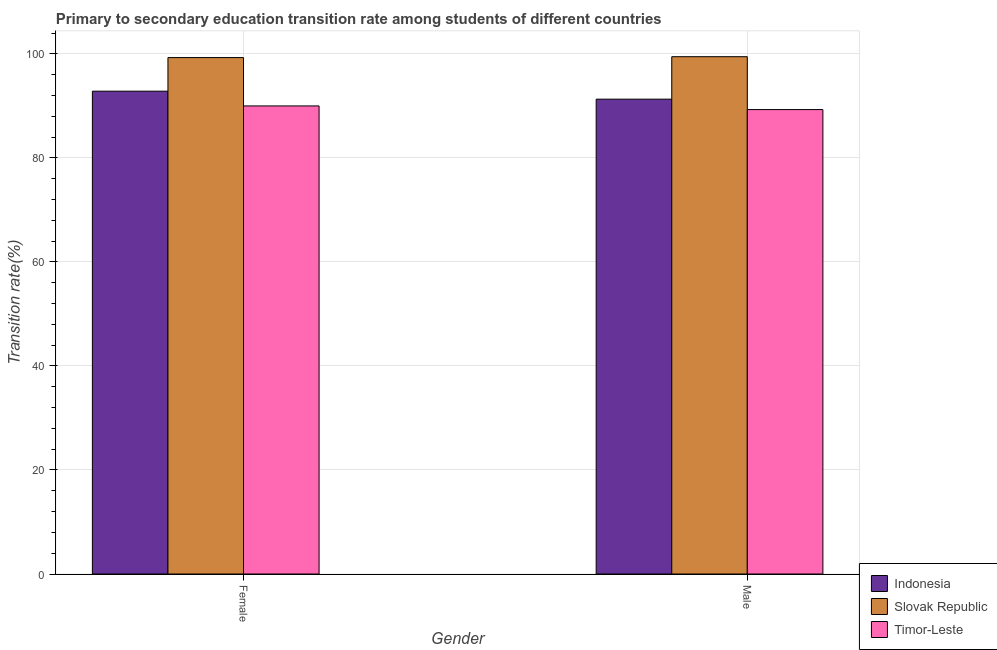How many different coloured bars are there?
Offer a very short reply. 3. Are the number of bars on each tick of the X-axis equal?
Offer a terse response. Yes. What is the transition rate among female students in Indonesia?
Give a very brief answer. 92.84. Across all countries, what is the maximum transition rate among male students?
Ensure brevity in your answer.  99.47. Across all countries, what is the minimum transition rate among male students?
Keep it short and to the point. 89.3. In which country was the transition rate among female students maximum?
Your answer should be compact. Slovak Republic. In which country was the transition rate among male students minimum?
Keep it short and to the point. Timor-Leste. What is the total transition rate among female students in the graph?
Make the answer very short. 282.15. What is the difference between the transition rate among female students in Timor-Leste and that in Slovak Republic?
Make the answer very short. -9.29. What is the difference between the transition rate among female students in Slovak Republic and the transition rate among male students in Timor-Leste?
Keep it short and to the point. 10. What is the average transition rate among female students per country?
Make the answer very short. 94.05. What is the difference between the transition rate among female students and transition rate among male students in Indonesia?
Your response must be concise. 1.54. What is the ratio of the transition rate among male students in Slovak Republic to that in Indonesia?
Provide a succinct answer. 1.09. What does the 2nd bar from the left in Female represents?
Your answer should be compact. Slovak Republic. What does the 1st bar from the right in Male represents?
Keep it short and to the point. Timor-Leste. How many bars are there?
Keep it short and to the point. 6. Are all the bars in the graph horizontal?
Keep it short and to the point. No. What is the difference between two consecutive major ticks on the Y-axis?
Make the answer very short. 20. Are the values on the major ticks of Y-axis written in scientific E-notation?
Give a very brief answer. No. Does the graph contain any zero values?
Offer a terse response. No. How many legend labels are there?
Your answer should be very brief. 3. What is the title of the graph?
Keep it short and to the point. Primary to secondary education transition rate among students of different countries. Does "Mongolia" appear as one of the legend labels in the graph?
Your answer should be compact. No. What is the label or title of the Y-axis?
Ensure brevity in your answer.  Transition rate(%). What is the Transition rate(%) of Indonesia in Female?
Offer a terse response. 92.84. What is the Transition rate(%) in Slovak Republic in Female?
Give a very brief answer. 99.3. What is the Transition rate(%) of Timor-Leste in Female?
Ensure brevity in your answer.  90.01. What is the Transition rate(%) in Indonesia in Male?
Provide a succinct answer. 91.31. What is the Transition rate(%) of Slovak Republic in Male?
Ensure brevity in your answer.  99.47. What is the Transition rate(%) in Timor-Leste in Male?
Ensure brevity in your answer.  89.3. Across all Gender, what is the maximum Transition rate(%) of Indonesia?
Offer a very short reply. 92.84. Across all Gender, what is the maximum Transition rate(%) in Slovak Republic?
Ensure brevity in your answer.  99.47. Across all Gender, what is the maximum Transition rate(%) in Timor-Leste?
Provide a succinct answer. 90.01. Across all Gender, what is the minimum Transition rate(%) of Indonesia?
Make the answer very short. 91.31. Across all Gender, what is the minimum Transition rate(%) in Slovak Republic?
Offer a very short reply. 99.3. Across all Gender, what is the minimum Transition rate(%) in Timor-Leste?
Ensure brevity in your answer.  89.3. What is the total Transition rate(%) of Indonesia in the graph?
Your answer should be compact. 184.15. What is the total Transition rate(%) of Slovak Republic in the graph?
Provide a succinct answer. 198.77. What is the total Transition rate(%) of Timor-Leste in the graph?
Your response must be concise. 179.31. What is the difference between the Transition rate(%) in Indonesia in Female and that in Male?
Make the answer very short. 1.54. What is the difference between the Transition rate(%) in Slovak Republic in Female and that in Male?
Offer a terse response. -0.17. What is the difference between the Transition rate(%) of Timor-Leste in Female and that in Male?
Keep it short and to the point. 0.7. What is the difference between the Transition rate(%) of Indonesia in Female and the Transition rate(%) of Slovak Republic in Male?
Your response must be concise. -6.63. What is the difference between the Transition rate(%) in Indonesia in Female and the Transition rate(%) in Timor-Leste in Male?
Ensure brevity in your answer.  3.54. What is the difference between the Transition rate(%) of Slovak Republic in Female and the Transition rate(%) of Timor-Leste in Male?
Offer a terse response. 10. What is the average Transition rate(%) of Indonesia per Gender?
Your answer should be compact. 92.07. What is the average Transition rate(%) of Slovak Republic per Gender?
Provide a short and direct response. 99.39. What is the average Transition rate(%) of Timor-Leste per Gender?
Your answer should be very brief. 89.66. What is the difference between the Transition rate(%) in Indonesia and Transition rate(%) in Slovak Republic in Female?
Provide a succinct answer. -6.46. What is the difference between the Transition rate(%) of Indonesia and Transition rate(%) of Timor-Leste in Female?
Provide a succinct answer. 2.83. What is the difference between the Transition rate(%) of Slovak Republic and Transition rate(%) of Timor-Leste in Female?
Ensure brevity in your answer.  9.29. What is the difference between the Transition rate(%) in Indonesia and Transition rate(%) in Slovak Republic in Male?
Your response must be concise. -8.17. What is the difference between the Transition rate(%) of Indonesia and Transition rate(%) of Timor-Leste in Male?
Your answer should be compact. 2. What is the difference between the Transition rate(%) of Slovak Republic and Transition rate(%) of Timor-Leste in Male?
Your answer should be very brief. 10.17. What is the ratio of the Transition rate(%) of Indonesia in Female to that in Male?
Give a very brief answer. 1.02. What is the ratio of the Transition rate(%) in Slovak Republic in Female to that in Male?
Your answer should be compact. 1. What is the ratio of the Transition rate(%) of Timor-Leste in Female to that in Male?
Make the answer very short. 1.01. What is the difference between the highest and the second highest Transition rate(%) in Indonesia?
Provide a succinct answer. 1.54. What is the difference between the highest and the second highest Transition rate(%) of Slovak Republic?
Your response must be concise. 0.17. What is the difference between the highest and the second highest Transition rate(%) of Timor-Leste?
Your answer should be very brief. 0.7. What is the difference between the highest and the lowest Transition rate(%) in Indonesia?
Offer a very short reply. 1.54. What is the difference between the highest and the lowest Transition rate(%) in Slovak Republic?
Provide a short and direct response. 0.17. What is the difference between the highest and the lowest Transition rate(%) in Timor-Leste?
Ensure brevity in your answer.  0.7. 